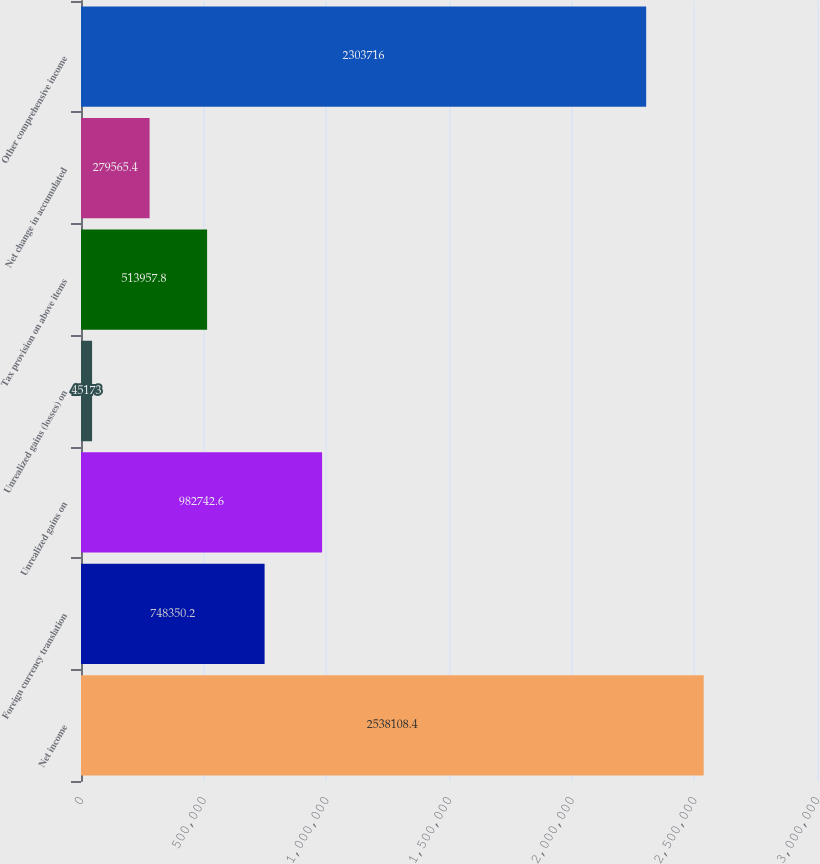Convert chart to OTSL. <chart><loc_0><loc_0><loc_500><loc_500><bar_chart><fcel>Net income<fcel>Foreign currency translation<fcel>Unrealized gains on<fcel>Unrealized gains (losses) on<fcel>Tax provision on above items<fcel>Net change in accumulated<fcel>Other comprehensive income<nl><fcel>2.53811e+06<fcel>748350<fcel>982743<fcel>45173<fcel>513958<fcel>279565<fcel>2.30372e+06<nl></chart> 